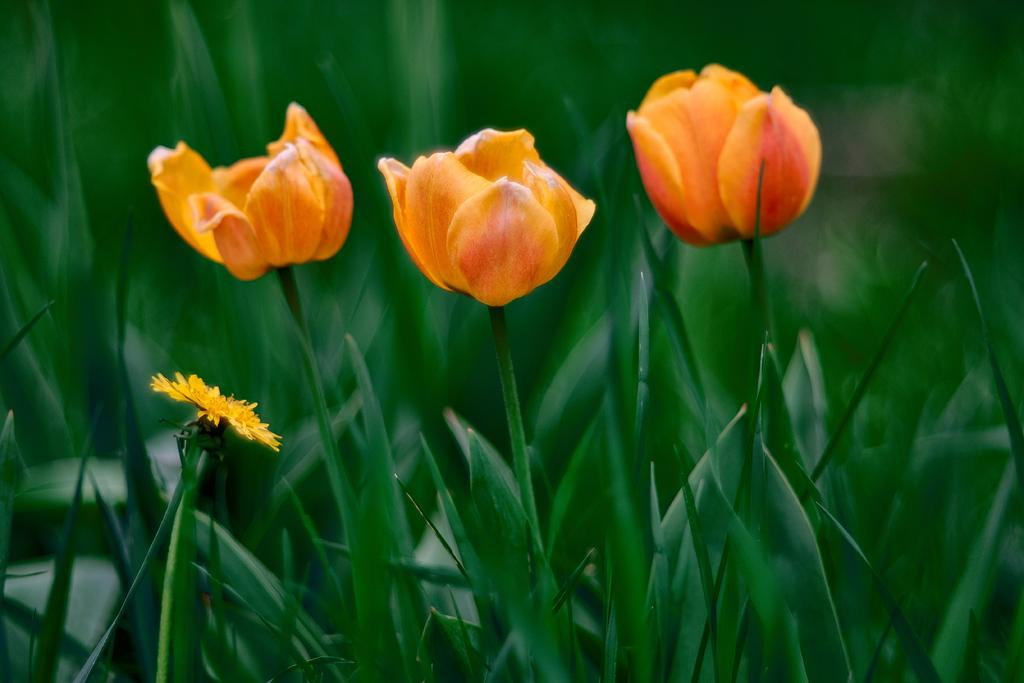What type of plants can be seen in the image? There are flowers in the image. What colors are the flowers? The flowers are yellow and orange in color. What can be seen in the background of the image? The background of the image is greenery. How many spiders are crawling on the kite in the image? There is no kite or spiders present in the image. What type of stranger can be seen interacting with the flowers in the image? There is no stranger present in the image; only flowers are visible. 